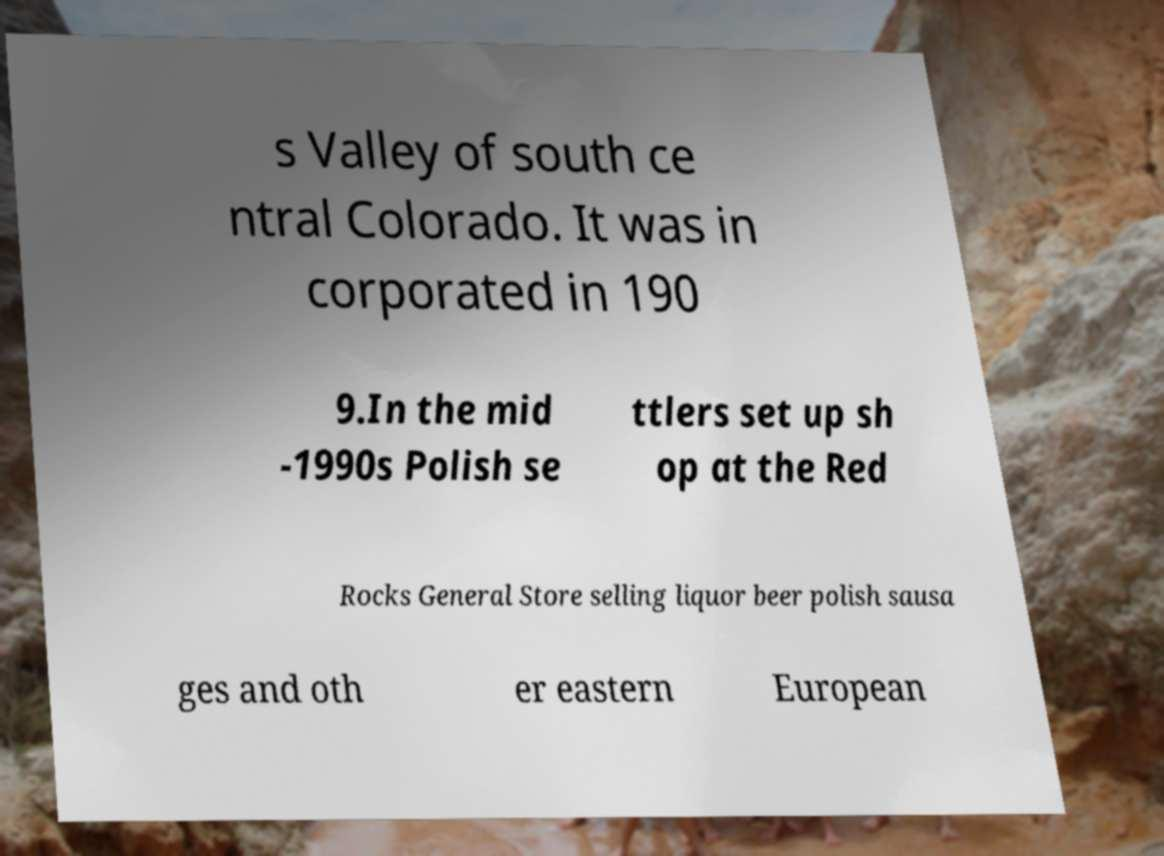Could you extract and type out the text from this image? s Valley of south ce ntral Colorado. It was in corporated in 190 9.In the mid -1990s Polish se ttlers set up sh op at the Red Rocks General Store selling liquor beer polish sausa ges and oth er eastern European 